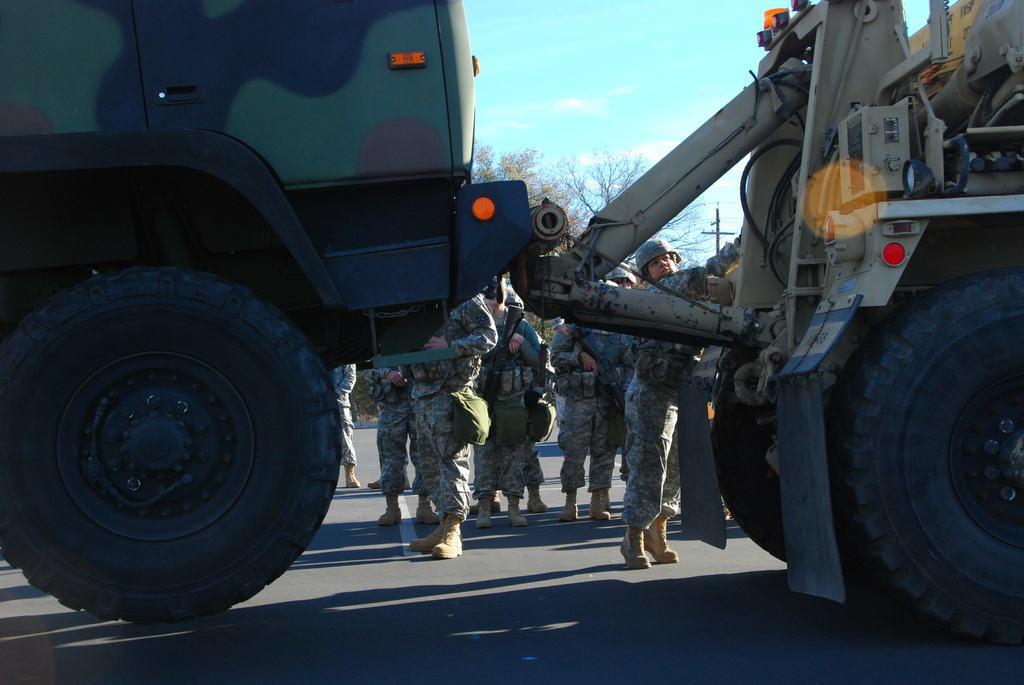Please provide a concise description of this image. In this image, at the left side we can see a truck, at the right side there is a towing vehicle, there are some people standing, in the background there are some trees, at the top there is a sky. 